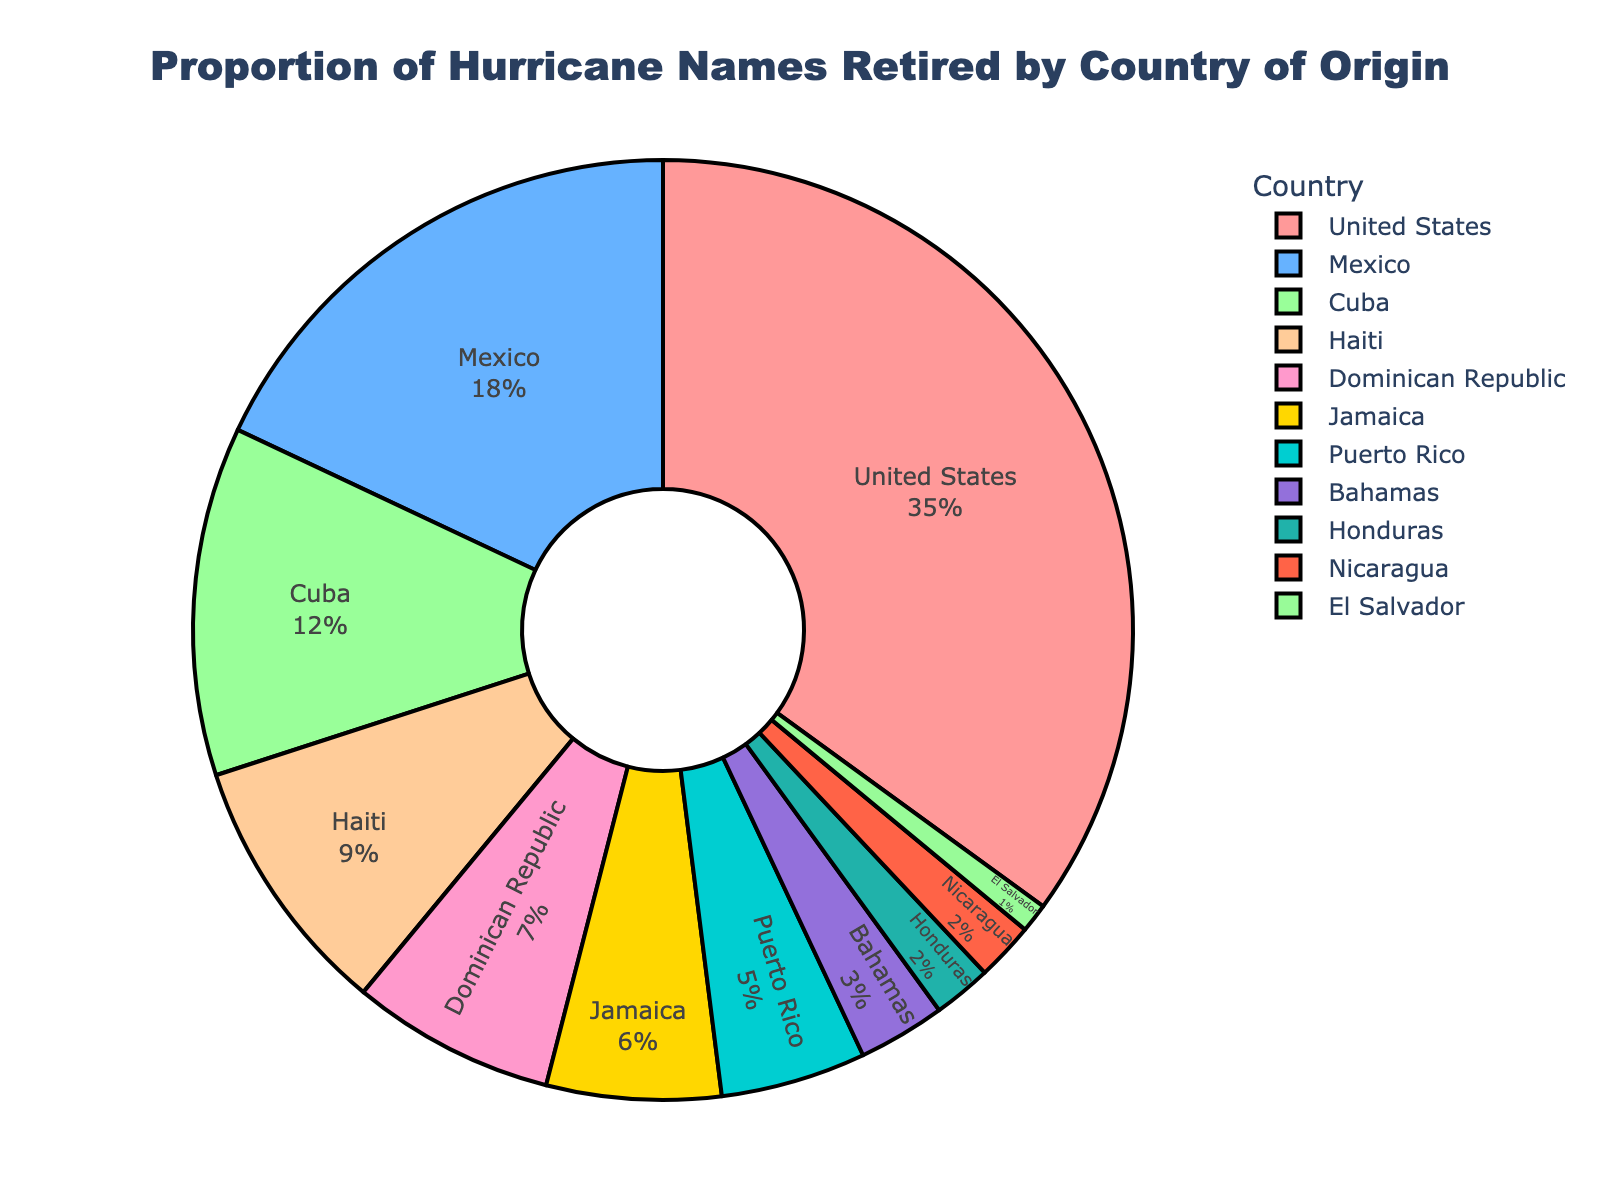Which country has the highest proportion of retired hurricane names? The pie chart visually indicates that the United States segment has the largest proportion. It appears larger and occupies a significant part of the chart.
Answer: United States What combined proportion of retired hurricane names comes from Mexico and Cuba? Sum the proportions of Mexico (0.18) and Cuba (0.12): 0.18 + 0.12 = 0.30.
Answer: 0.30 Which country has a higher proportion of retired hurricane names, Haiti or the Dominican Republic? Compare the proportions: Haiti has 0.09 and the Dominican Republic has 0.07. 0.09 is greater than 0.07.
Answer: Haiti How much more is the proportion of retired hurricane names from the United States compared to Jamaica? Subtract Jamaica's proportion (0.06) from the United States' proportion (0.35): 0.35 - 0.06 = 0.29.
Answer: 0.29 Which countries have proportions of retired hurricane names smaller than 0.05? The pie chart lists countries with proportions. Puerto Rico (0.05) is exactly 0.05 so it is not counted. Bahamas (0.03), Honduras (0.02), Nicaragua (0.02), and El Salvador (0.01) are all smaller than 0.05.
Answer: Bahamas, Honduras, Nicaragua, El Salvador What is the total proportion of retired hurricane names originating from the Caribbean (Cuba, Haiti, Dominican Republic, Jamaica, Puerto Rico)? Sum the proportions of these countries: Cuba (0.12), Haiti (0.09), Dominican Republic (0.07), Jamaica (0.06), and Puerto Rico (0.05): 0.12 + 0.09 + 0.07 + 0.06 + 0.05 = 0.39.
Answer: 0.39 Which region has the smallest representation in the chart based on the retired hurricane names? Identify the smallest segment visually, which corresponds to El Salvador with a proportion of 0.01.
Answer: El Salvador 